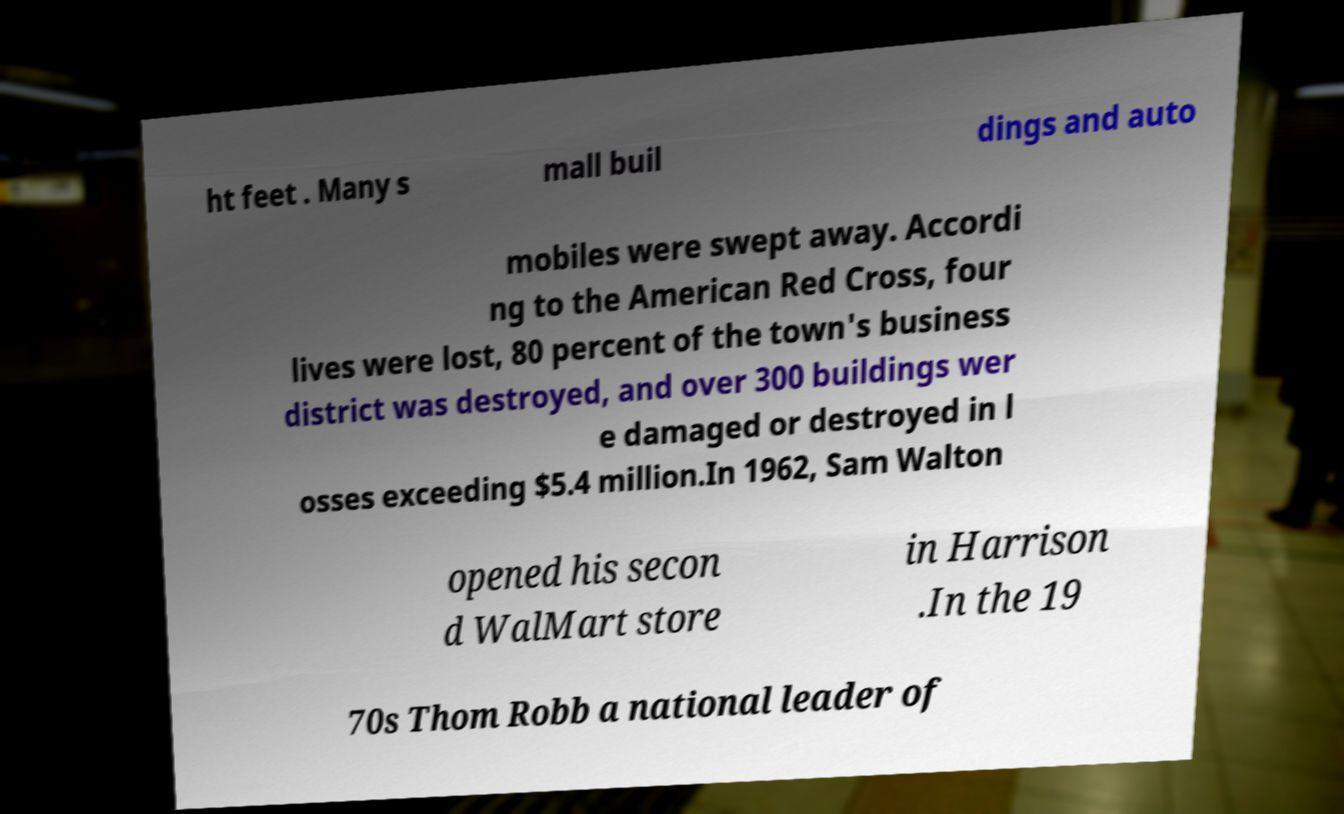Please read and relay the text visible in this image. What does it say? ht feet . Many s mall buil dings and auto mobiles were swept away. Accordi ng to the American Red Cross, four lives were lost, 80 percent of the town's business district was destroyed, and over 300 buildings wer e damaged or destroyed in l osses exceeding $5.4 million.In 1962, Sam Walton opened his secon d WalMart store in Harrison .In the 19 70s Thom Robb a national leader of 